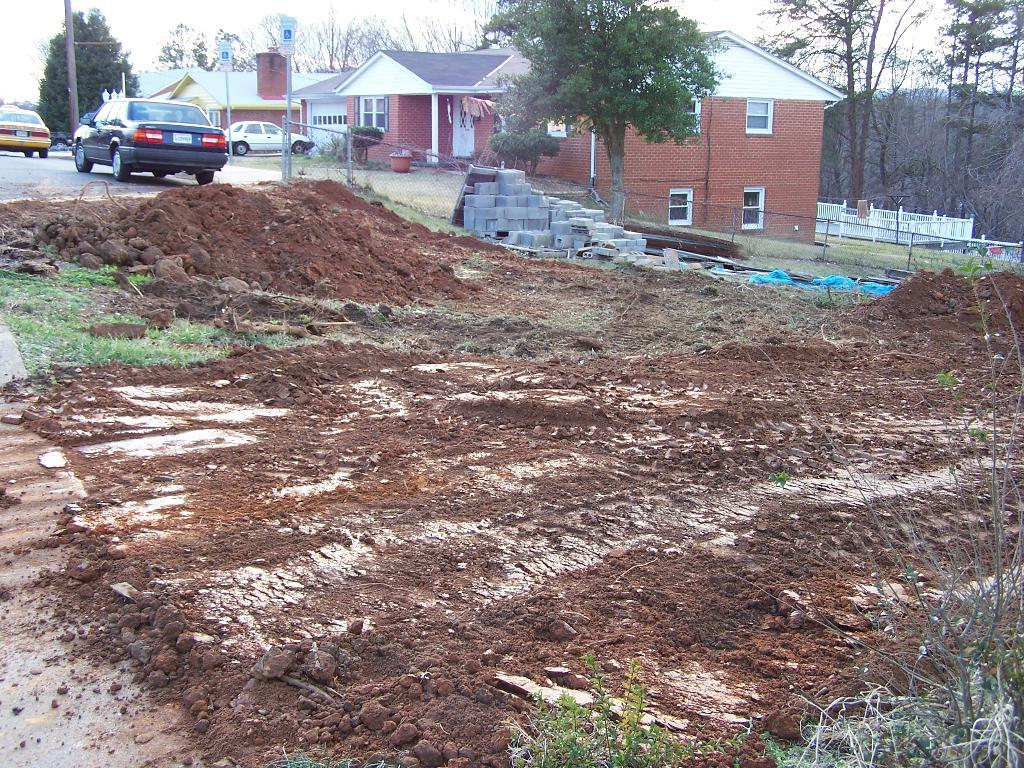What can be seen at the bottom of the image? The ground is visible in the image. What is located in the distance in the image? There are houses, poles, trees, vehicles, and the sky visible in the background of the image. Can you describe the unspecified objects in the background of the image? Unfortunately, the facts provided do not specify the nature of these unspecified objects. What type of school can be seen in the image? There is no school present in the image. How many hydrants are visible in the image? There is no hydrant present in the image. 